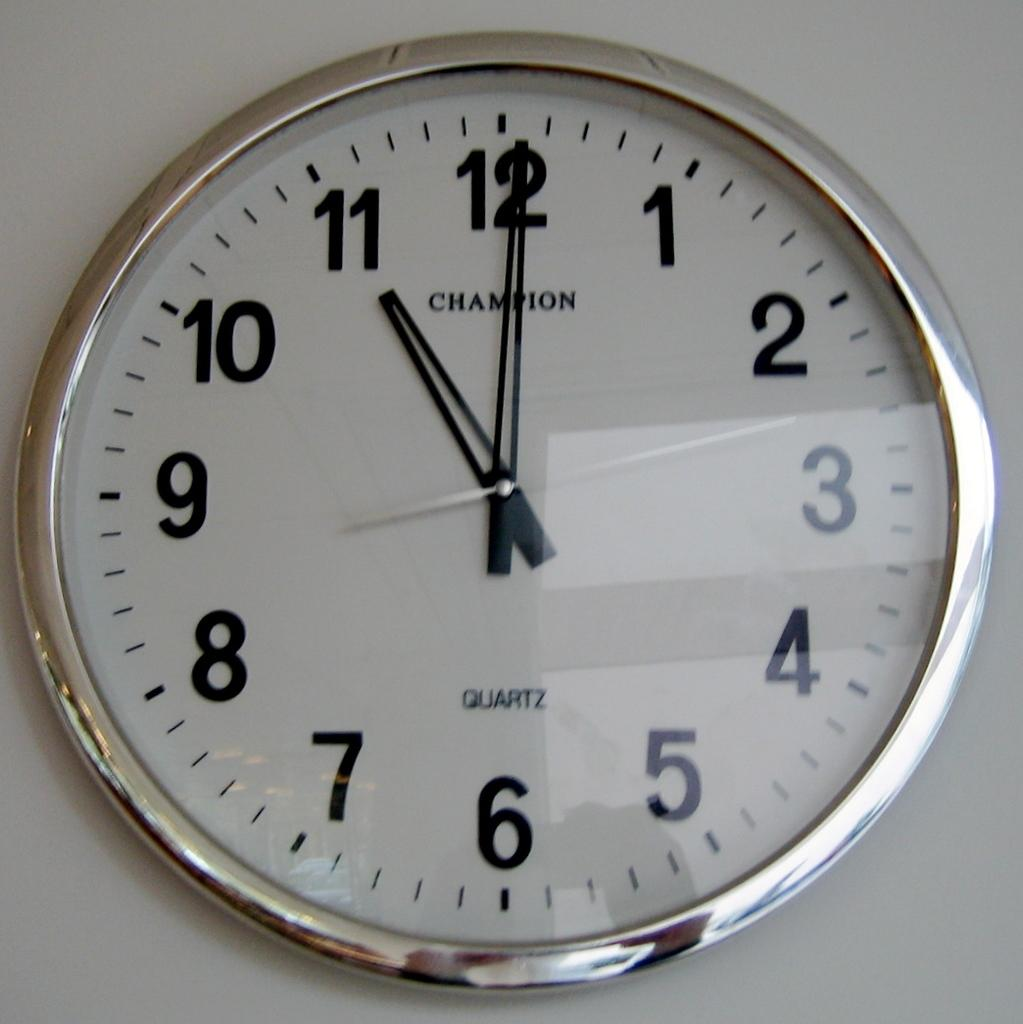<image>
Relay a brief, clear account of the picture shown. Champion Clock that says it is 11:00 with the word Quartz. 